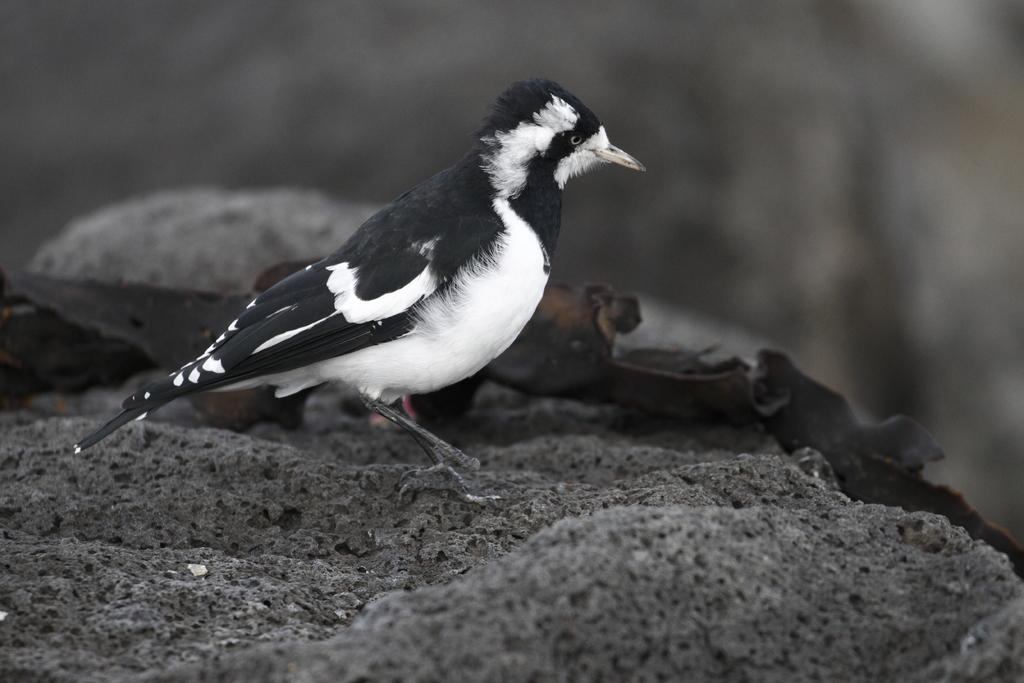What type of bird can be seen in the image? There is a black and white bird in the image. Can you describe the background of the image? The background of the image is blurred. What is the bird's annual income in the image? There is no information about the bird's income in the image, as birds do not have incomes. 